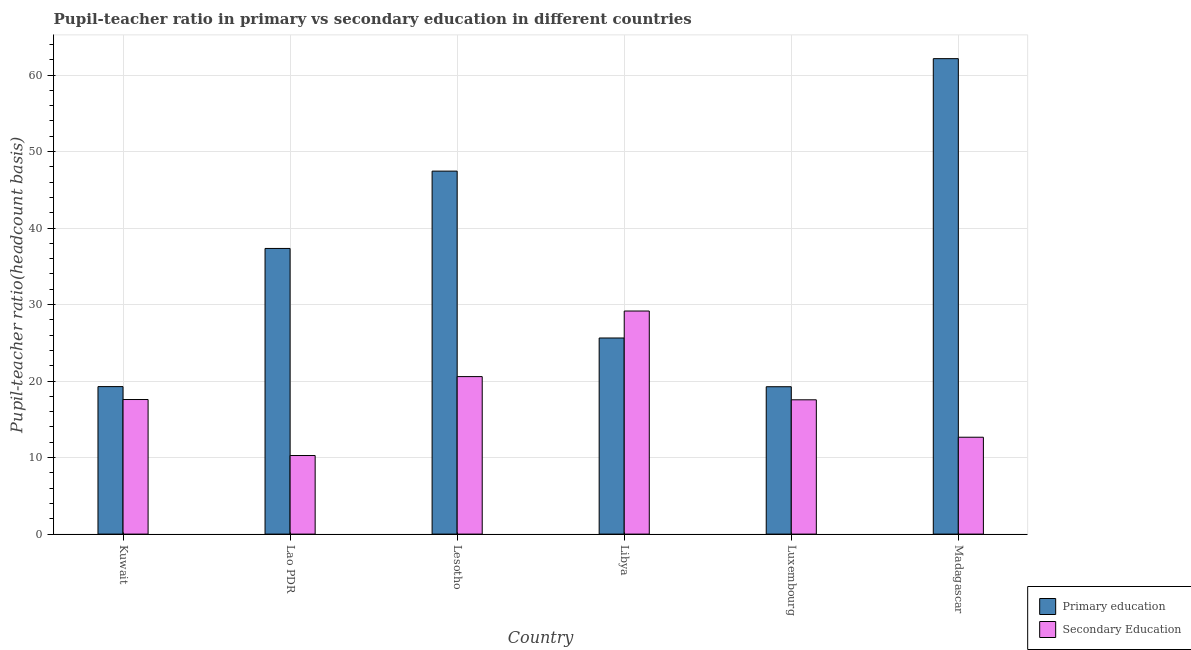How many groups of bars are there?
Your response must be concise. 6. Are the number of bars on each tick of the X-axis equal?
Ensure brevity in your answer.  Yes. How many bars are there on the 3rd tick from the left?
Ensure brevity in your answer.  2. What is the label of the 6th group of bars from the left?
Your answer should be very brief. Madagascar. What is the pupil teacher ratio on secondary education in Madagascar?
Ensure brevity in your answer.  12.66. Across all countries, what is the maximum pupil-teacher ratio in primary education?
Give a very brief answer. 62.15. Across all countries, what is the minimum pupil teacher ratio on secondary education?
Ensure brevity in your answer.  10.27. In which country was the pupil-teacher ratio in primary education maximum?
Provide a succinct answer. Madagascar. In which country was the pupil-teacher ratio in primary education minimum?
Ensure brevity in your answer.  Luxembourg. What is the total pupil-teacher ratio in primary education in the graph?
Offer a terse response. 211.11. What is the difference between the pupil teacher ratio on secondary education in Kuwait and that in Lao PDR?
Offer a terse response. 7.32. What is the difference between the pupil-teacher ratio in primary education in Madagascar and the pupil teacher ratio on secondary education in Lao PDR?
Provide a short and direct response. 51.88. What is the average pupil-teacher ratio in primary education per country?
Give a very brief answer. 35.18. What is the difference between the pupil-teacher ratio in primary education and pupil teacher ratio on secondary education in Lesotho?
Give a very brief answer. 26.86. In how many countries, is the pupil teacher ratio on secondary education greater than 24 ?
Your answer should be very brief. 1. What is the ratio of the pupil teacher ratio on secondary education in Kuwait to that in Madagascar?
Your response must be concise. 1.39. Is the pupil-teacher ratio in primary education in Kuwait less than that in Lesotho?
Your response must be concise. Yes. What is the difference between the highest and the second highest pupil teacher ratio on secondary education?
Your response must be concise. 8.57. What is the difference between the highest and the lowest pupil-teacher ratio in primary education?
Your response must be concise. 42.88. Is the sum of the pupil teacher ratio on secondary education in Kuwait and Lesotho greater than the maximum pupil-teacher ratio in primary education across all countries?
Provide a short and direct response. No. What does the 2nd bar from the right in Luxembourg represents?
Provide a short and direct response. Primary education. How many bars are there?
Your response must be concise. 12. What is the difference between two consecutive major ticks on the Y-axis?
Make the answer very short. 10. Are the values on the major ticks of Y-axis written in scientific E-notation?
Ensure brevity in your answer.  No. Does the graph contain any zero values?
Provide a short and direct response. No. Does the graph contain grids?
Make the answer very short. Yes. How are the legend labels stacked?
Provide a succinct answer. Vertical. What is the title of the graph?
Your answer should be very brief. Pupil-teacher ratio in primary vs secondary education in different countries. Does "Drinking water services" appear as one of the legend labels in the graph?
Give a very brief answer. No. What is the label or title of the Y-axis?
Your answer should be compact. Pupil-teacher ratio(headcount basis). What is the Pupil-teacher ratio(headcount basis) in Primary education in Kuwait?
Make the answer very short. 19.28. What is the Pupil-teacher ratio(headcount basis) in Secondary Education in Kuwait?
Your response must be concise. 17.59. What is the Pupil-teacher ratio(headcount basis) in Primary education in Lao PDR?
Provide a succinct answer. 37.34. What is the Pupil-teacher ratio(headcount basis) of Secondary Education in Lao PDR?
Offer a very short reply. 10.27. What is the Pupil-teacher ratio(headcount basis) of Primary education in Lesotho?
Make the answer very short. 47.45. What is the Pupil-teacher ratio(headcount basis) in Secondary Education in Lesotho?
Your answer should be compact. 20.59. What is the Pupil-teacher ratio(headcount basis) in Primary education in Libya?
Give a very brief answer. 25.63. What is the Pupil-teacher ratio(headcount basis) of Secondary Education in Libya?
Offer a very short reply. 29.16. What is the Pupil-teacher ratio(headcount basis) in Primary education in Luxembourg?
Your answer should be compact. 19.26. What is the Pupil-teacher ratio(headcount basis) in Secondary Education in Luxembourg?
Your answer should be very brief. 17.55. What is the Pupil-teacher ratio(headcount basis) of Primary education in Madagascar?
Your answer should be very brief. 62.15. What is the Pupil-teacher ratio(headcount basis) in Secondary Education in Madagascar?
Your answer should be compact. 12.66. Across all countries, what is the maximum Pupil-teacher ratio(headcount basis) of Primary education?
Offer a terse response. 62.15. Across all countries, what is the maximum Pupil-teacher ratio(headcount basis) of Secondary Education?
Keep it short and to the point. 29.16. Across all countries, what is the minimum Pupil-teacher ratio(headcount basis) in Primary education?
Your answer should be very brief. 19.26. Across all countries, what is the minimum Pupil-teacher ratio(headcount basis) of Secondary Education?
Offer a very short reply. 10.27. What is the total Pupil-teacher ratio(headcount basis) of Primary education in the graph?
Provide a succinct answer. 211.11. What is the total Pupil-teacher ratio(headcount basis) in Secondary Education in the graph?
Give a very brief answer. 107.83. What is the difference between the Pupil-teacher ratio(headcount basis) of Primary education in Kuwait and that in Lao PDR?
Ensure brevity in your answer.  -18.06. What is the difference between the Pupil-teacher ratio(headcount basis) in Secondary Education in Kuwait and that in Lao PDR?
Provide a succinct answer. 7.32. What is the difference between the Pupil-teacher ratio(headcount basis) of Primary education in Kuwait and that in Lesotho?
Your answer should be very brief. -28.17. What is the difference between the Pupil-teacher ratio(headcount basis) of Secondary Education in Kuwait and that in Lesotho?
Give a very brief answer. -3. What is the difference between the Pupil-teacher ratio(headcount basis) in Primary education in Kuwait and that in Libya?
Offer a terse response. -6.36. What is the difference between the Pupil-teacher ratio(headcount basis) in Secondary Education in Kuwait and that in Libya?
Provide a short and direct response. -11.57. What is the difference between the Pupil-teacher ratio(headcount basis) in Primary education in Kuwait and that in Luxembourg?
Your answer should be very brief. 0.02. What is the difference between the Pupil-teacher ratio(headcount basis) of Secondary Education in Kuwait and that in Luxembourg?
Offer a terse response. 0.04. What is the difference between the Pupil-teacher ratio(headcount basis) of Primary education in Kuwait and that in Madagascar?
Make the answer very short. -42.87. What is the difference between the Pupil-teacher ratio(headcount basis) of Secondary Education in Kuwait and that in Madagascar?
Keep it short and to the point. 4.93. What is the difference between the Pupil-teacher ratio(headcount basis) in Primary education in Lao PDR and that in Lesotho?
Your answer should be compact. -10.11. What is the difference between the Pupil-teacher ratio(headcount basis) of Secondary Education in Lao PDR and that in Lesotho?
Your answer should be compact. -10.32. What is the difference between the Pupil-teacher ratio(headcount basis) of Primary education in Lao PDR and that in Libya?
Your response must be concise. 11.7. What is the difference between the Pupil-teacher ratio(headcount basis) in Secondary Education in Lao PDR and that in Libya?
Offer a terse response. -18.89. What is the difference between the Pupil-teacher ratio(headcount basis) in Primary education in Lao PDR and that in Luxembourg?
Your response must be concise. 18.08. What is the difference between the Pupil-teacher ratio(headcount basis) in Secondary Education in Lao PDR and that in Luxembourg?
Offer a very short reply. -7.28. What is the difference between the Pupil-teacher ratio(headcount basis) of Primary education in Lao PDR and that in Madagascar?
Give a very brief answer. -24.81. What is the difference between the Pupil-teacher ratio(headcount basis) in Secondary Education in Lao PDR and that in Madagascar?
Make the answer very short. -2.39. What is the difference between the Pupil-teacher ratio(headcount basis) in Primary education in Lesotho and that in Libya?
Offer a very short reply. 21.81. What is the difference between the Pupil-teacher ratio(headcount basis) in Secondary Education in Lesotho and that in Libya?
Your answer should be compact. -8.57. What is the difference between the Pupil-teacher ratio(headcount basis) in Primary education in Lesotho and that in Luxembourg?
Your answer should be compact. 28.18. What is the difference between the Pupil-teacher ratio(headcount basis) in Secondary Education in Lesotho and that in Luxembourg?
Give a very brief answer. 3.03. What is the difference between the Pupil-teacher ratio(headcount basis) of Primary education in Lesotho and that in Madagascar?
Your response must be concise. -14.7. What is the difference between the Pupil-teacher ratio(headcount basis) in Secondary Education in Lesotho and that in Madagascar?
Your response must be concise. 7.92. What is the difference between the Pupil-teacher ratio(headcount basis) of Primary education in Libya and that in Luxembourg?
Provide a succinct answer. 6.37. What is the difference between the Pupil-teacher ratio(headcount basis) of Secondary Education in Libya and that in Luxembourg?
Ensure brevity in your answer.  11.6. What is the difference between the Pupil-teacher ratio(headcount basis) in Primary education in Libya and that in Madagascar?
Give a very brief answer. -36.51. What is the difference between the Pupil-teacher ratio(headcount basis) of Secondary Education in Libya and that in Madagascar?
Ensure brevity in your answer.  16.5. What is the difference between the Pupil-teacher ratio(headcount basis) of Primary education in Luxembourg and that in Madagascar?
Ensure brevity in your answer.  -42.88. What is the difference between the Pupil-teacher ratio(headcount basis) of Secondary Education in Luxembourg and that in Madagascar?
Your answer should be compact. 4.89. What is the difference between the Pupil-teacher ratio(headcount basis) of Primary education in Kuwait and the Pupil-teacher ratio(headcount basis) of Secondary Education in Lao PDR?
Provide a short and direct response. 9.01. What is the difference between the Pupil-teacher ratio(headcount basis) in Primary education in Kuwait and the Pupil-teacher ratio(headcount basis) in Secondary Education in Lesotho?
Offer a terse response. -1.31. What is the difference between the Pupil-teacher ratio(headcount basis) of Primary education in Kuwait and the Pupil-teacher ratio(headcount basis) of Secondary Education in Libya?
Provide a succinct answer. -9.88. What is the difference between the Pupil-teacher ratio(headcount basis) of Primary education in Kuwait and the Pupil-teacher ratio(headcount basis) of Secondary Education in Luxembourg?
Offer a terse response. 1.72. What is the difference between the Pupil-teacher ratio(headcount basis) in Primary education in Kuwait and the Pupil-teacher ratio(headcount basis) in Secondary Education in Madagascar?
Keep it short and to the point. 6.62. What is the difference between the Pupil-teacher ratio(headcount basis) of Primary education in Lao PDR and the Pupil-teacher ratio(headcount basis) of Secondary Education in Lesotho?
Ensure brevity in your answer.  16.75. What is the difference between the Pupil-teacher ratio(headcount basis) of Primary education in Lao PDR and the Pupil-teacher ratio(headcount basis) of Secondary Education in Libya?
Ensure brevity in your answer.  8.18. What is the difference between the Pupil-teacher ratio(headcount basis) in Primary education in Lao PDR and the Pupil-teacher ratio(headcount basis) in Secondary Education in Luxembourg?
Ensure brevity in your answer.  19.78. What is the difference between the Pupil-teacher ratio(headcount basis) of Primary education in Lao PDR and the Pupil-teacher ratio(headcount basis) of Secondary Education in Madagascar?
Your answer should be compact. 24.68. What is the difference between the Pupil-teacher ratio(headcount basis) of Primary education in Lesotho and the Pupil-teacher ratio(headcount basis) of Secondary Education in Libya?
Your response must be concise. 18.29. What is the difference between the Pupil-teacher ratio(headcount basis) of Primary education in Lesotho and the Pupil-teacher ratio(headcount basis) of Secondary Education in Luxembourg?
Offer a terse response. 29.89. What is the difference between the Pupil-teacher ratio(headcount basis) in Primary education in Lesotho and the Pupil-teacher ratio(headcount basis) in Secondary Education in Madagascar?
Keep it short and to the point. 34.78. What is the difference between the Pupil-teacher ratio(headcount basis) in Primary education in Libya and the Pupil-teacher ratio(headcount basis) in Secondary Education in Luxembourg?
Offer a terse response. 8.08. What is the difference between the Pupil-teacher ratio(headcount basis) in Primary education in Libya and the Pupil-teacher ratio(headcount basis) in Secondary Education in Madagascar?
Offer a very short reply. 12.97. What is the difference between the Pupil-teacher ratio(headcount basis) in Primary education in Luxembourg and the Pupil-teacher ratio(headcount basis) in Secondary Education in Madagascar?
Ensure brevity in your answer.  6.6. What is the average Pupil-teacher ratio(headcount basis) in Primary education per country?
Offer a very short reply. 35.18. What is the average Pupil-teacher ratio(headcount basis) in Secondary Education per country?
Provide a short and direct response. 17.97. What is the difference between the Pupil-teacher ratio(headcount basis) in Primary education and Pupil-teacher ratio(headcount basis) in Secondary Education in Kuwait?
Your answer should be very brief. 1.69. What is the difference between the Pupil-teacher ratio(headcount basis) of Primary education and Pupil-teacher ratio(headcount basis) of Secondary Education in Lao PDR?
Offer a very short reply. 27.07. What is the difference between the Pupil-teacher ratio(headcount basis) of Primary education and Pupil-teacher ratio(headcount basis) of Secondary Education in Lesotho?
Give a very brief answer. 26.86. What is the difference between the Pupil-teacher ratio(headcount basis) of Primary education and Pupil-teacher ratio(headcount basis) of Secondary Education in Libya?
Ensure brevity in your answer.  -3.52. What is the difference between the Pupil-teacher ratio(headcount basis) in Primary education and Pupil-teacher ratio(headcount basis) in Secondary Education in Luxembourg?
Give a very brief answer. 1.71. What is the difference between the Pupil-teacher ratio(headcount basis) of Primary education and Pupil-teacher ratio(headcount basis) of Secondary Education in Madagascar?
Your answer should be very brief. 49.48. What is the ratio of the Pupil-teacher ratio(headcount basis) in Primary education in Kuwait to that in Lao PDR?
Your answer should be very brief. 0.52. What is the ratio of the Pupil-teacher ratio(headcount basis) in Secondary Education in Kuwait to that in Lao PDR?
Your response must be concise. 1.71. What is the ratio of the Pupil-teacher ratio(headcount basis) in Primary education in Kuwait to that in Lesotho?
Ensure brevity in your answer.  0.41. What is the ratio of the Pupil-teacher ratio(headcount basis) in Secondary Education in Kuwait to that in Lesotho?
Your answer should be very brief. 0.85. What is the ratio of the Pupil-teacher ratio(headcount basis) in Primary education in Kuwait to that in Libya?
Offer a very short reply. 0.75. What is the ratio of the Pupil-teacher ratio(headcount basis) of Secondary Education in Kuwait to that in Libya?
Your response must be concise. 0.6. What is the ratio of the Pupil-teacher ratio(headcount basis) in Primary education in Kuwait to that in Luxembourg?
Your response must be concise. 1. What is the ratio of the Pupil-teacher ratio(headcount basis) in Primary education in Kuwait to that in Madagascar?
Give a very brief answer. 0.31. What is the ratio of the Pupil-teacher ratio(headcount basis) of Secondary Education in Kuwait to that in Madagascar?
Make the answer very short. 1.39. What is the ratio of the Pupil-teacher ratio(headcount basis) in Primary education in Lao PDR to that in Lesotho?
Keep it short and to the point. 0.79. What is the ratio of the Pupil-teacher ratio(headcount basis) in Secondary Education in Lao PDR to that in Lesotho?
Your answer should be very brief. 0.5. What is the ratio of the Pupil-teacher ratio(headcount basis) of Primary education in Lao PDR to that in Libya?
Provide a short and direct response. 1.46. What is the ratio of the Pupil-teacher ratio(headcount basis) of Secondary Education in Lao PDR to that in Libya?
Your response must be concise. 0.35. What is the ratio of the Pupil-teacher ratio(headcount basis) in Primary education in Lao PDR to that in Luxembourg?
Ensure brevity in your answer.  1.94. What is the ratio of the Pupil-teacher ratio(headcount basis) in Secondary Education in Lao PDR to that in Luxembourg?
Make the answer very short. 0.59. What is the ratio of the Pupil-teacher ratio(headcount basis) of Primary education in Lao PDR to that in Madagascar?
Offer a very short reply. 0.6. What is the ratio of the Pupil-teacher ratio(headcount basis) in Secondary Education in Lao PDR to that in Madagascar?
Your response must be concise. 0.81. What is the ratio of the Pupil-teacher ratio(headcount basis) of Primary education in Lesotho to that in Libya?
Your response must be concise. 1.85. What is the ratio of the Pupil-teacher ratio(headcount basis) of Secondary Education in Lesotho to that in Libya?
Ensure brevity in your answer.  0.71. What is the ratio of the Pupil-teacher ratio(headcount basis) in Primary education in Lesotho to that in Luxembourg?
Offer a very short reply. 2.46. What is the ratio of the Pupil-teacher ratio(headcount basis) of Secondary Education in Lesotho to that in Luxembourg?
Your response must be concise. 1.17. What is the ratio of the Pupil-teacher ratio(headcount basis) in Primary education in Lesotho to that in Madagascar?
Your response must be concise. 0.76. What is the ratio of the Pupil-teacher ratio(headcount basis) in Secondary Education in Lesotho to that in Madagascar?
Ensure brevity in your answer.  1.63. What is the ratio of the Pupil-teacher ratio(headcount basis) of Primary education in Libya to that in Luxembourg?
Make the answer very short. 1.33. What is the ratio of the Pupil-teacher ratio(headcount basis) in Secondary Education in Libya to that in Luxembourg?
Offer a very short reply. 1.66. What is the ratio of the Pupil-teacher ratio(headcount basis) in Primary education in Libya to that in Madagascar?
Make the answer very short. 0.41. What is the ratio of the Pupil-teacher ratio(headcount basis) in Secondary Education in Libya to that in Madagascar?
Keep it short and to the point. 2.3. What is the ratio of the Pupil-teacher ratio(headcount basis) in Primary education in Luxembourg to that in Madagascar?
Provide a short and direct response. 0.31. What is the ratio of the Pupil-teacher ratio(headcount basis) of Secondary Education in Luxembourg to that in Madagascar?
Ensure brevity in your answer.  1.39. What is the difference between the highest and the second highest Pupil-teacher ratio(headcount basis) in Primary education?
Your answer should be compact. 14.7. What is the difference between the highest and the second highest Pupil-teacher ratio(headcount basis) of Secondary Education?
Your answer should be compact. 8.57. What is the difference between the highest and the lowest Pupil-teacher ratio(headcount basis) of Primary education?
Give a very brief answer. 42.88. What is the difference between the highest and the lowest Pupil-teacher ratio(headcount basis) of Secondary Education?
Keep it short and to the point. 18.89. 